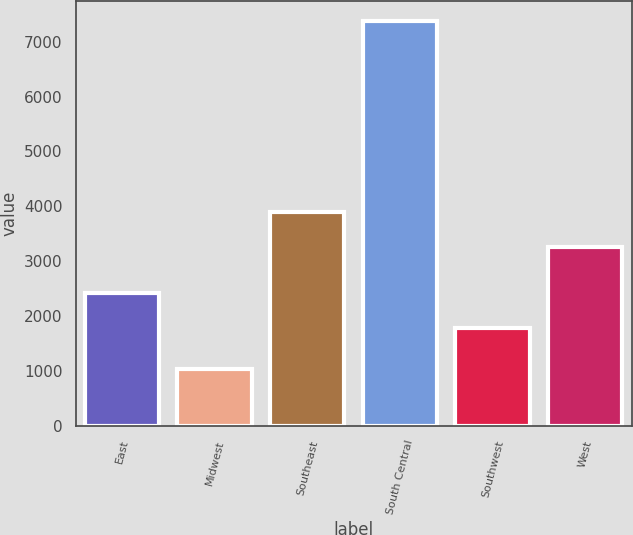Convert chart. <chart><loc_0><loc_0><loc_500><loc_500><bar_chart><fcel>East<fcel>Midwest<fcel>Southeast<fcel>South Central<fcel>Southwest<fcel>West<nl><fcel>2418<fcel>1045<fcel>3892<fcel>7375<fcel>1785<fcel>3251<nl></chart> 